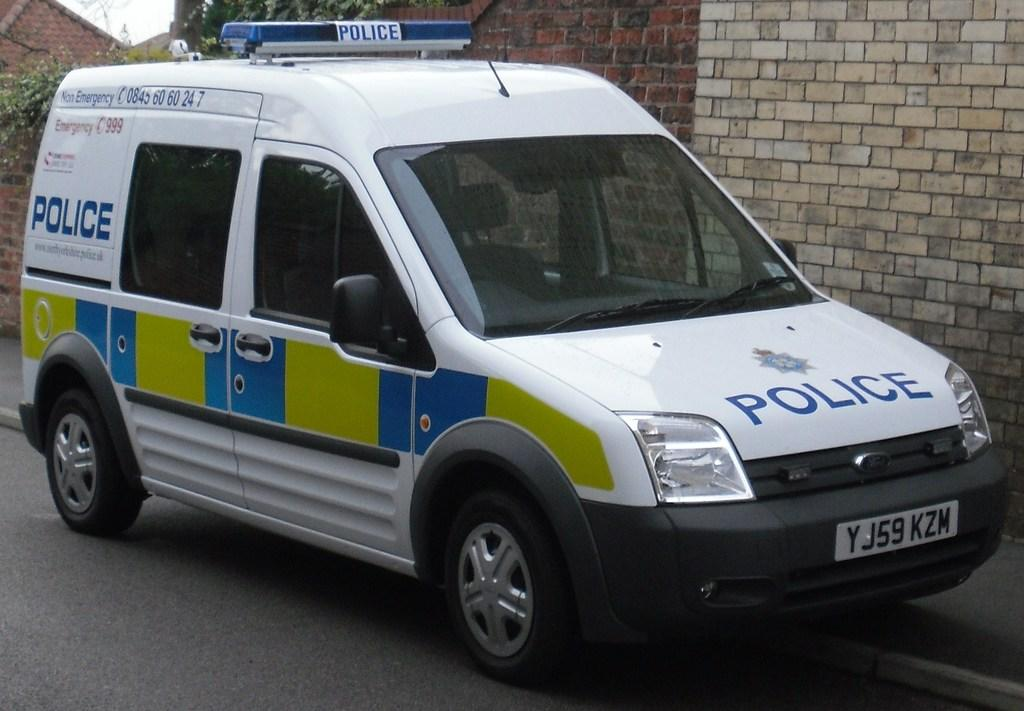<image>
Create a compact narrative representing the image presented. A white, blue and green police van is parked on a street. 